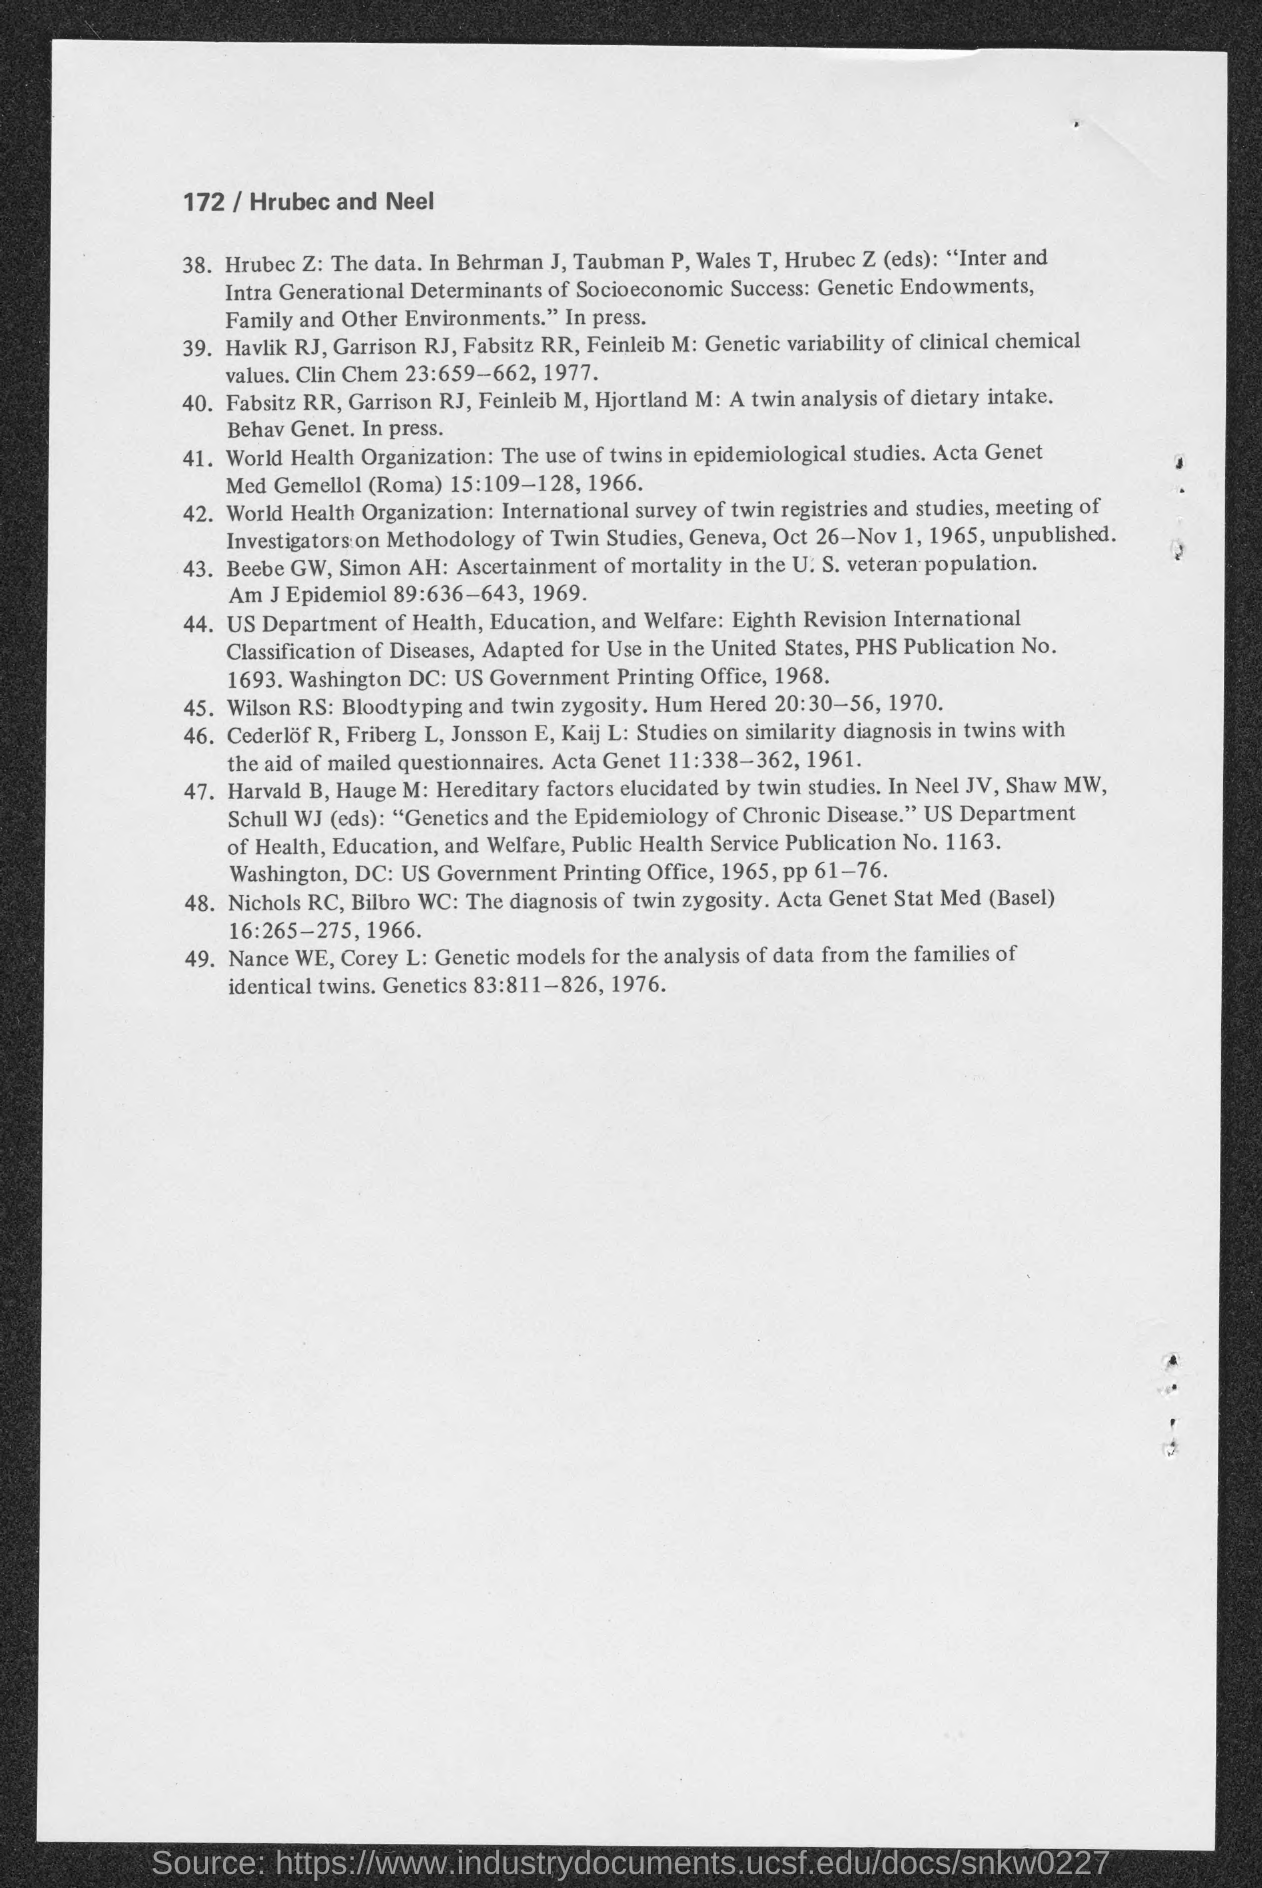In which year, does "Nance WE" publish his book ?
Offer a terse response. 1976. 